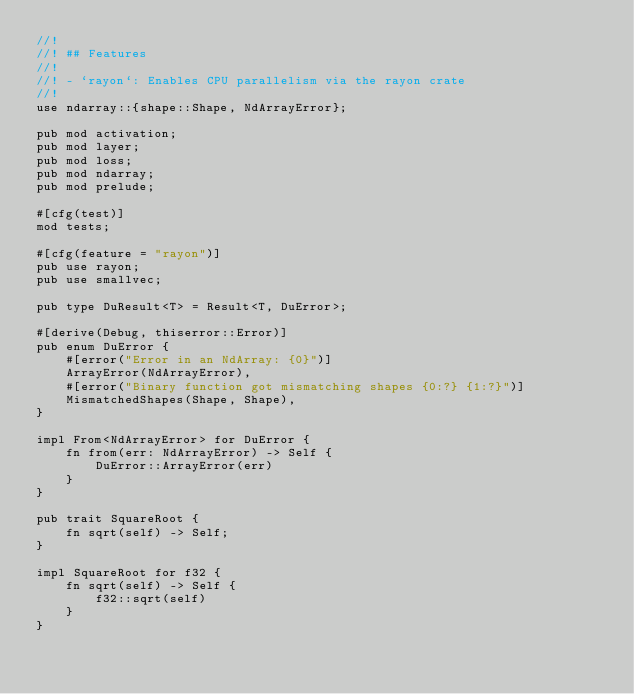Convert code to text. <code><loc_0><loc_0><loc_500><loc_500><_Rust_>//!
//! ## Features
//!
//! - `rayon`: Enables CPU parallelism via the rayon crate
//!
use ndarray::{shape::Shape, NdArrayError};

pub mod activation;
pub mod layer;
pub mod loss;
pub mod ndarray;
pub mod prelude;

#[cfg(test)]
mod tests;

#[cfg(feature = "rayon")]
pub use rayon;
pub use smallvec;

pub type DuResult<T> = Result<T, DuError>;

#[derive(Debug, thiserror::Error)]
pub enum DuError {
    #[error("Error in an NdArray: {0}")]
    ArrayError(NdArrayError),
    #[error("Binary function got mismatching shapes {0:?} {1:?}")]
    MismatchedShapes(Shape, Shape),
}

impl From<NdArrayError> for DuError {
    fn from(err: NdArrayError) -> Self {
        DuError::ArrayError(err)
    }
}

pub trait SquareRoot {
    fn sqrt(self) -> Self;
}

impl SquareRoot for f32 {
    fn sqrt(self) -> Self {
        f32::sqrt(self)
    }
}
</code> 